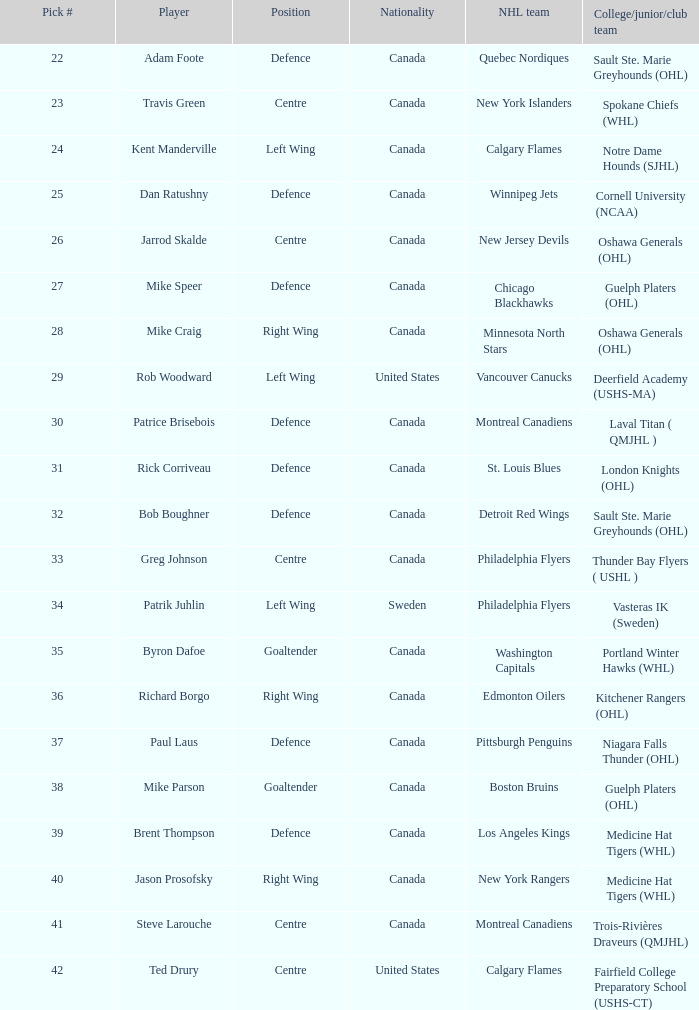What is the national identity of the player drafted to the washington capitals? Canada. Would you be able to parse every entry in this table? {'header': ['Pick #', 'Player', 'Position', 'Nationality', 'NHL team', 'College/junior/club team'], 'rows': [['22', 'Adam Foote', 'Defence', 'Canada', 'Quebec Nordiques', 'Sault Ste. Marie Greyhounds (OHL)'], ['23', 'Travis Green', 'Centre', 'Canada', 'New York Islanders', 'Spokane Chiefs (WHL)'], ['24', 'Kent Manderville', 'Left Wing', 'Canada', 'Calgary Flames', 'Notre Dame Hounds (SJHL)'], ['25', 'Dan Ratushny', 'Defence', 'Canada', 'Winnipeg Jets', 'Cornell University (NCAA)'], ['26', 'Jarrod Skalde', 'Centre', 'Canada', 'New Jersey Devils', 'Oshawa Generals (OHL)'], ['27', 'Mike Speer', 'Defence', 'Canada', 'Chicago Blackhawks', 'Guelph Platers (OHL)'], ['28', 'Mike Craig', 'Right Wing', 'Canada', 'Minnesota North Stars', 'Oshawa Generals (OHL)'], ['29', 'Rob Woodward', 'Left Wing', 'United States', 'Vancouver Canucks', 'Deerfield Academy (USHS-MA)'], ['30', 'Patrice Brisebois', 'Defence', 'Canada', 'Montreal Canadiens', 'Laval Titan ( QMJHL )'], ['31', 'Rick Corriveau', 'Defence', 'Canada', 'St. Louis Blues', 'London Knights (OHL)'], ['32', 'Bob Boughner', 'Defence', 'Canada', 'Detroit Red Wings', 'Sault Ste. Marie Greyhounds (OHL)'], ['33', 'Greg Johnson', 'Centre', 'Canada', 'Philadelphia Flyers', 'Thunder Bay Flyers ( USHL )'], ['34', 'Patrik Juhlin', 'Left Wing', 'Sweden', 'Philadelphia Flyers', 'Vasteras IK (Sweden)'], ['35', 'Byron Dafoe', 'Goaltender', 'Canada', 'Washington Capitals', 'Portland Winter Hawks (WHL)'], ['36', 'Richard Borgo', 'Right Wing', 'Canada', 'Edmonton Oilers', 'Kitchener Rangers (OHL)'], ['37', 'Paul Laus', 'Defence', 'Canada', 'Pittsburgh Penguins', 'Niagara Falls Thunder (OHL)'], ['38', 'Mike Parson', 'Goaltender', 'Canada', 'Boston Bruins', 'Guelph Platers (OHL)'], ['39', 'Brent Thompson', 'Defence', 'Canada', 'Los Angeles Kings', 'Medicine Hat Tigers (WHL)'], ['40', 'Jason Prosofsky', 'Right Wing', 'Canada', 'New York Rangers', 'Medicine Hat Tigers (WHL)'], ['41', 'Steve Larouche', 'Centre', 'Canada', 'Montreal Canadiens', 'Trois-Rivières Draveurs (QMJHL)'], ['42', 'Ted Drury', 'Centre', 'United States', 'Calgary Flames', 'Fairfield College Preparatory School (USHS-CT)']]} 